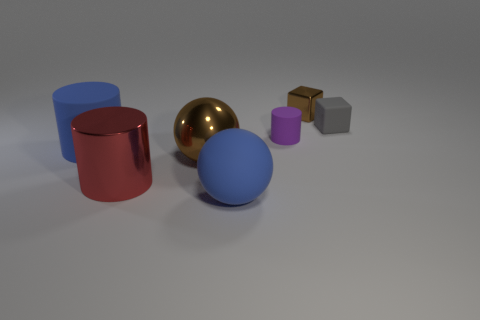What is the material of the tiny block that is the same color as the metallic sphere?
Your answer should be very brief. Metal. Do the purple object and the gray thing have the same size?
Offer a very short reply. Yes. Are there more big things on the left side of the large brown metallic object than large green matte cubes?
Your answer should be compact. Yes. What number of other objects are there of the same shape as the purple object?
Offer a very short reply. 2. What is the large object that is both right of the red metal thing and behind the matte ball made of?
Offer a terse response. Metal. What number of objects are tiny brown rubber cubes or tiny objects?
Give a very brief answer. 3. Are there more large brown spheres than brown objects?
Offer a very short reply. No. There is a cube that is on the right side of the small block left of the gray object; how big is it?
Offer a very short reply. Small. What color is the other large metallic thing that is the same shape as the purple thing?
Make the answer very short. Red. How big is the blue matte sphere?
Offer a very short reply. Large. 